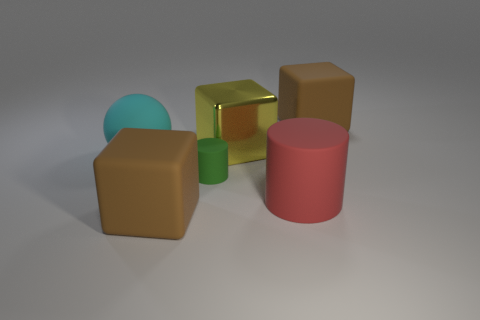Add 3 green matte cylinders. How many objects exist? 9 Subtract all cylinders. How many objects are left? 4 Subtract 0 gray cubes. How many objects are left? 6 Subtract all large metallic cubes. Subtract all cyan matte things. How many objects are left? 4 Add 1 small matte cylinders. How many small matte cylinders are left? 2 Add 4 matte objects. How many matte objects exist? 9 